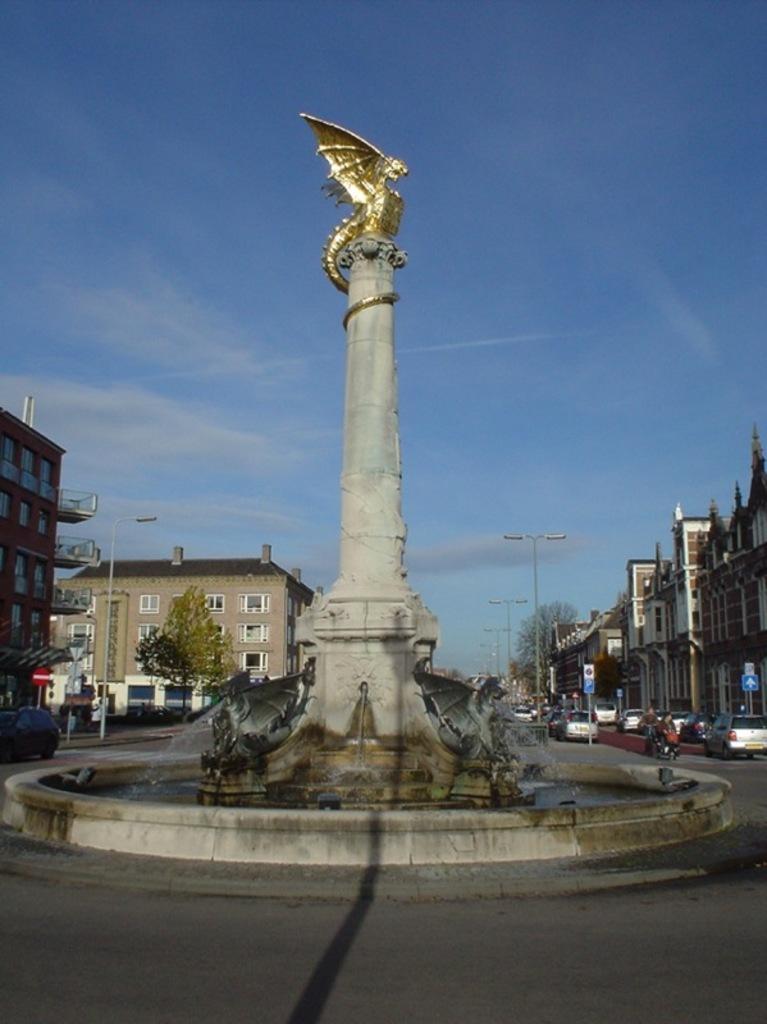Please provide a concise description of this image. This image shows about the stone pillar with golden dragon on the top seen in middle of the image. Behind there some buildings and cars parked around it. 